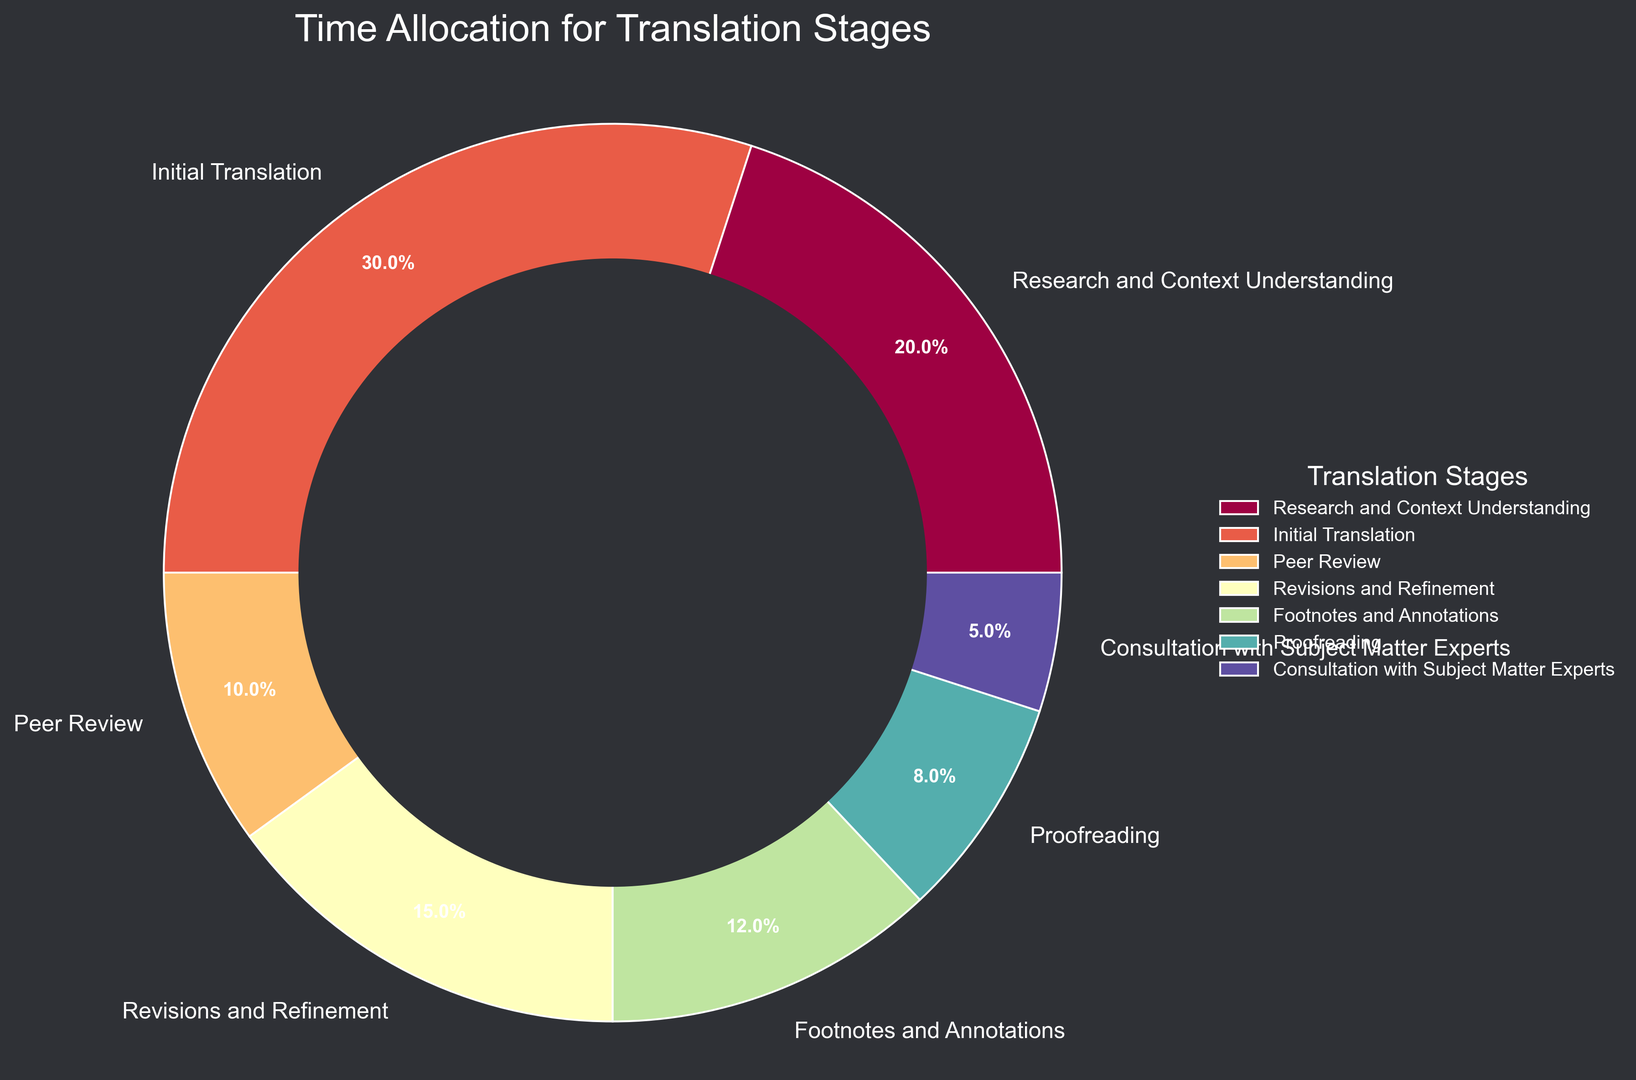What percentage of time is allocated to the Initial Translation stage? The Initial Translation stage occupies a specific portion of the pie chart, annotated directly with the percentage. We can see that the percentage for this stage is clearly marked.
Answer: 30% How much more time is spent on Research and Context Understanding compared to Peer Review? The pie chart shows that Research and Context Understanding is allocated 20% of the time, while Peer Review is allocated 10%. The difference between these two stages is calculated as 20% - 10% = 10%.
Answer: 10% Which stage receives the least amount of time? By examining the pie chart, the stage with the smallest wedge represents the least amount of allocated time. The Consultation with Subject Matter Experts stage has the smallest percentage, which is 5%.
Answer: Consultation with Subject Matter Experts If you sum the percentages of Footnotes and Annotations, Proofreading, and Consultation with Subject Matter Experts, what is the total? By looking at the pie chart, we find the percentages for Footnotes and Annotations (12%), Proofreading (8%), and Consultation with Subject Matter Experts (5%). Adding these up gives 12% + 8% + 5% = 25%.
Answer: 25% Is more time allocated to Revisions and Refinement or Footnotes and Annotations? The chart shows Revisions and Refinement with 15% and Footnotes and Annotations with 12%. Comparing these, 15% is greater than 12%, so more time is allocated to Revisions and Refinement.
Answer: Revisions and Refinement How do the combined times for Research and Context Understanding, and Initial Translation compare to the entire process? The percentages for Research and Context Understanding and Initial Translation are 20% and 30%, respectively. Summing these, 20% + 30% = 50%. Since the total time for all stages is 100%, half of the time is spent on these two stages.
Answer: 50% Which stages combined take up the same amount of time as Initial Translation alone? Initial Translation is allocated 30% of the time. To find stages that add up to the same percentage, we can combine Peer Review (10%) and Revisions and Refinement (15%) and Footnotes and Annotations (12%), as 10% + 15% + 12% = 37%. However, it’s exactly equal when combining Research and Context Understanding (20%) and Peer Review (10%), as 20% + 10% = 30%.
Answer: Research and Context Understanding and Peer Review What's the ratio of time spent on Proofreading to the time spent on Footnotes and Annotations? The pie chart indicates 8% for Proofreading and 12% for Footnotes and Annotations. The ratio is calculated as 8/12, which simplifies to 2/3.
Answer: 2 to 3 